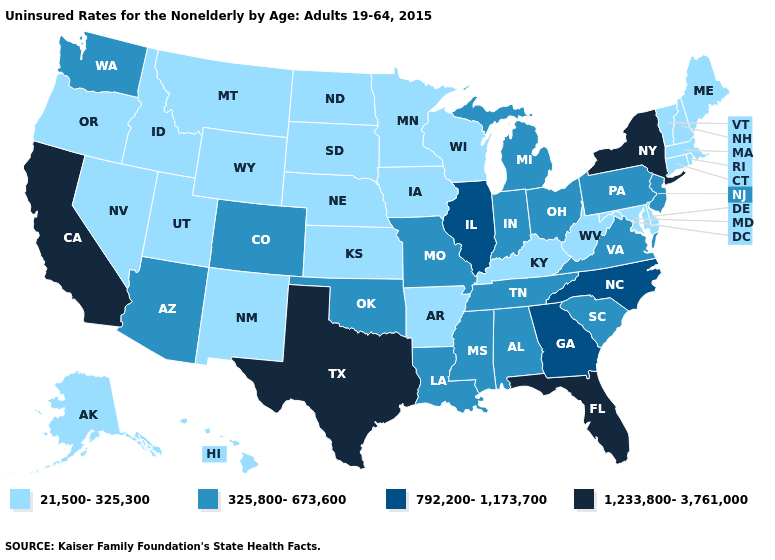Which states have the lowest value in the Northeast?
Write a very short answer. Connecticut, Maine, Massachusetts, New Hampshire, Rhode Island, Vermont. What is the value of Delaware?
Keep it brief. 21,500-325,300. Name the states that have a value in the range 21,500-325,300?
Answer briefly. Alaska, Arkansas, Connecticut, Delaware, Hawaii, Idaho, Iowa, Kansas, Kentucky, Maine, Maryland, Massachusetts, Minnesota, Montana, Nebraska, Nevada, New Hampshire, New Mexico, North Dakota, Oregon, Rhode Island, South Dakota, Utah, Vermont, West Virginia, Wisconsin, Wyoming. Name the states that have a value in the range 325,800-673,600?
Keep it brief. Alabama, Arizona, Colorado, Indiana, Louisiana, Michigan, Mississippi, Missouri, New Jersey, Ohio, Oklahoma, Pennsylvania, South Carolina, Tennessee, Virginia, Washington. Which states hav the highest value in the MidWest?
Be succinct. Illinois. Does the map have missing data?
Answer briefly. No. Among the states that border Maryland , which have the highest value?
Short answer required. Pennsylvania, Virginia. Does New York have a lower value than Colorado?
Keep it brief. No. Name the states that have a value in the range 21,500-325,300?
Concise answer only. Alaska, Arkansas, Connecticut, Delaware, Hawaii, Idaho, Iowa, Kansas, Kentucky, Maine, Maryland, Massachusetts, Minnesota, Montana, Nebraska, Nevada, New Hampshire, New Mexico, North Dakota, Oregon, Rhode Island, South Dakota, Utah, Vermont, West Virginia, Wisconsin, Wyoming. Which states hav the highest value in the MidWest?
Give a very brief answer. Illinois. What is the lowest value in states that border New Jersey?
Concise answer only. 21,500-325,300. What is the value of Illinois?
Write a very short answer. 792,200-1,173,700. What is the highest value in the USA?
Give a very brief answer. 1,233,800-3,761,000. Does Texas have the highest value in the South?
Concise answer only. Yes. What is the lowest value in states that border Louisiana?
Be succinct. 21,500-325,300. 